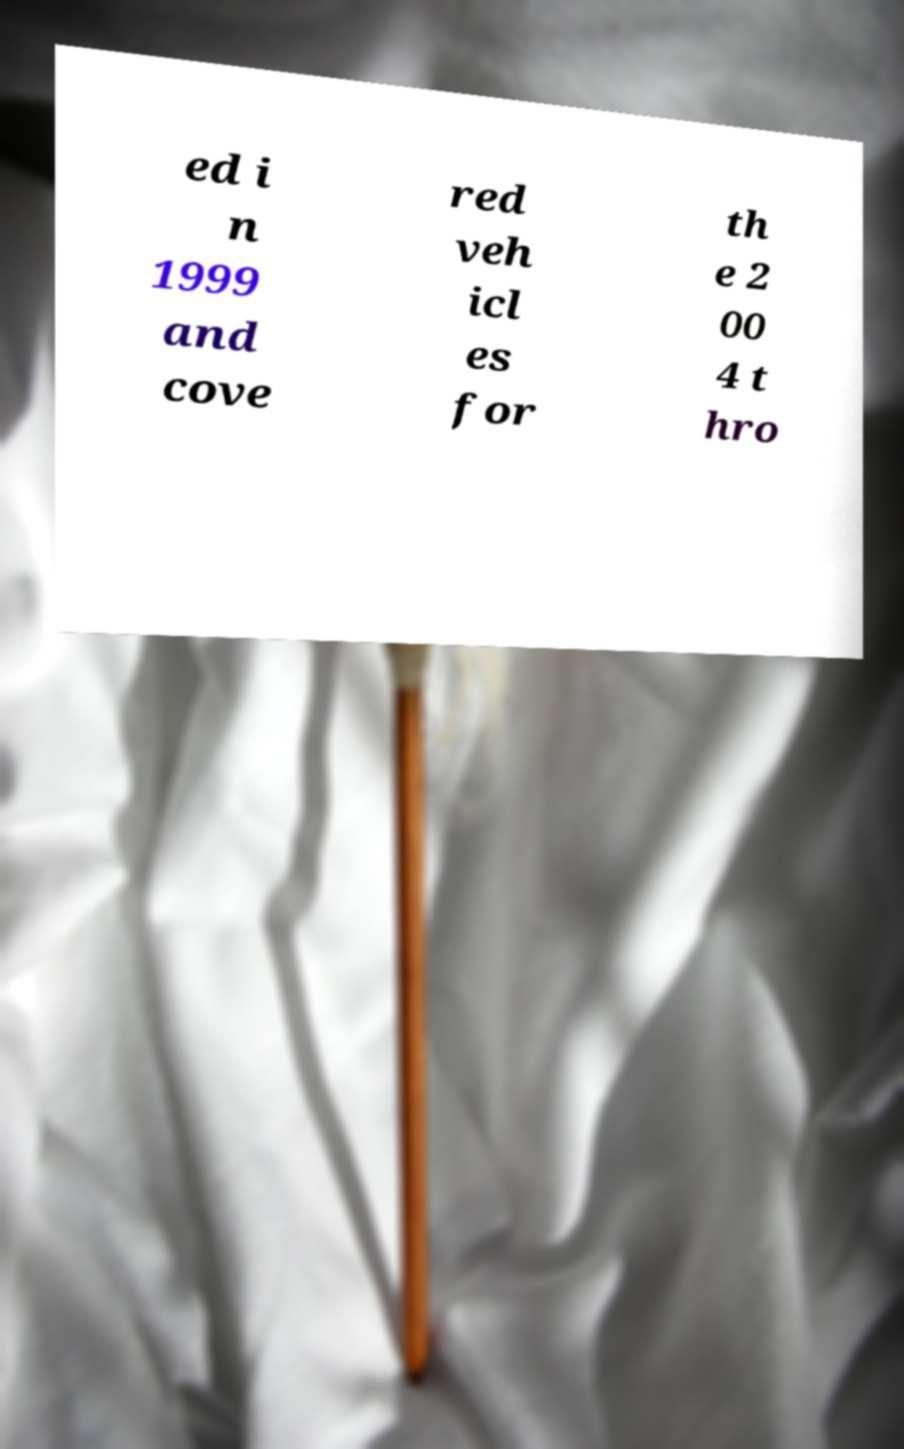There's text embedded in this image that I need extracted. Can you transcribe it verbatim? ed i n 1999 and cove red veh icl es for th e 2 00 4 t hro 